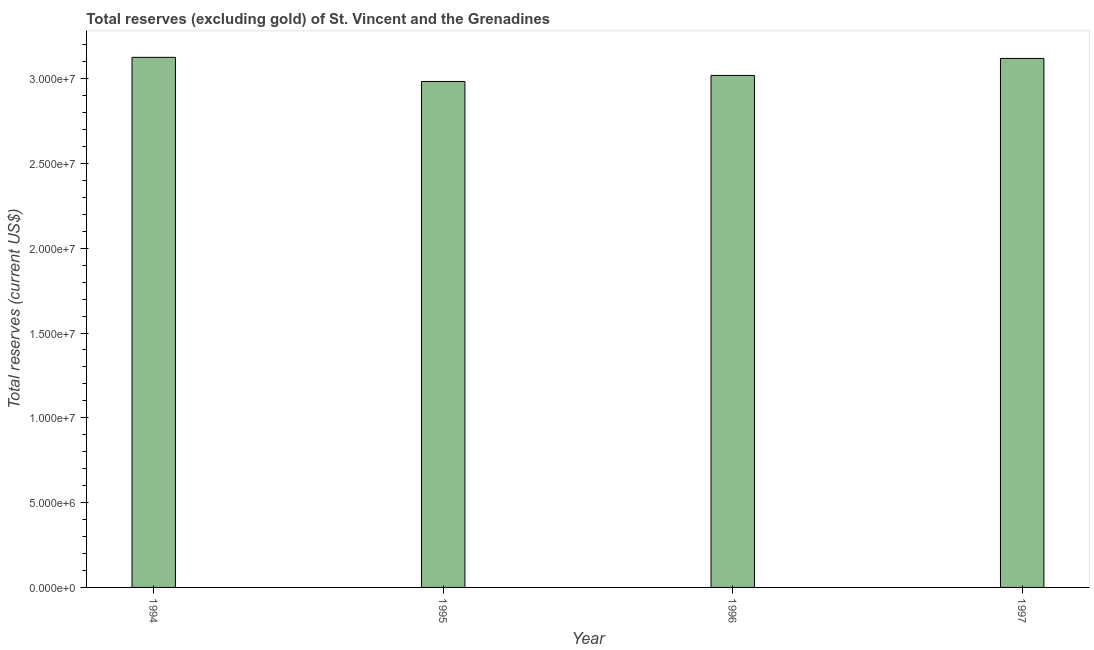What is the title of the graph?
Ensure brevity in your answer.  Total reserves (excluding gold) of St. Vincent and the Grenadines. What is the label or title of the X-axis?
Offer a very short reply. Year. What is the label or title of the Y-axis?
Ensure brevity in your answer.  Total reserves (current US$). What is the total reserves (excluding gold) in 1996?
Your answer should be very brief. 3.02e+07. Across all years, what is the maximum total reserves (excluding gold)?
Your answer should be compact. 3.13e+07. Across all years, what is the minimum total reserves (excluding gold)?
Provide a short and direct response. 2.98e+07. In which year was the total reserves (excluding gold) maximum?
Provide a short and direct response. 1994. What is the sum of the total reserves (excluding gold)?
Make the answer very short. 1.22e+08. What is the difference between the total reserves (excluding gold) in 1996 and 1997?
Provide a short and direct response. -1.00e+06. What is the average total reserves (excluding gold) per year?
Offer a terse response. 3.06e+07. What is the median total reserves (excluding gold)?
Provide a short and direct response. 3.07e+07. Do a majority of the years between 1997 and 1996 (inclusive) have total reserves (excluding gold) greater than 29000000 US$?
Offer a terse response. No. What is the ratio of the total reserves (excluding gold) in 1994 to that in 1996?
Keep it short and to the point. 1.03. Is the difference between the total reserves (excluding gold) in 1995 and 1996 greater than the difference between any two years?
Your answer should be very brief. No. What is the difference between the highest and the second highest total reserves (excluding gold)?
Provide a short and direct response. 6.53e+04. Is the sum of the total reserves (excluding gold) in 1994 and 1996 greater than the maximum total reserves (excluding gold) across all years?
Your answer should be compact. Yes. What is the difference between the highest and the lowest total reserves (excluding gold)?
Ensure brevity in your answer.  1.42e+06. In how many years, is the total reserves (excluding gold) greater than the average total reserves (excluding gold) taken over all years?
Keep it short and to the point. 2. Are all the bars in the graph horizontal?
Provide a succinct answer. No. What is the difference between two consecutive major ticks on the Y-axis?
Ensure brevity in your answer.  5.00e+06. Are the values on the major ticks of Y-axis written in scientific E-notation?
Provide a short and direct response. Yes. What is the Total reserves (current US$) in 1994?
Provide a short and direct response. 3.13e+07. What is the Total reserves (current US$) in 1995?
Offer a terse response. 2.98e+07. What is the Total reserves (current US$) of 1996?
Make the answer very short. 3.02e+07. What is the Total reserves (current US$) in 1997?
Your answer should be very brief. 3.12e+07. What is the difference between the Total reserves (current US$) in 1994 and 1995?
Offer a terse response. 1.42e+06. What is the difference between the Total reserves (current US$) in 1994 and 1996?
Give a very brief answer. 1.07e+06. What is the difference between the Total reserves (current US$) in 1994 and 1997?
Your answer should be very brief. 6.53e+04. What is the difference between the Total reserves (current US$) in 1995 and 1996?
Ensure brevity in your answer.  -3.55e+05. What is the difference between the Total reserves (current US$) in 1995 and 1997?
Your answer should be very brief. -1.36e+06. What is the difference between the Total reserves (current US$) in 1996 and 1997?
Keep it short and to the point. -1.00e+06. What is the ratio of the Total reserves (current US$) in 1994 to that in 1995?
Give a very brief answer. 1.05. What is the ratio of the Total reserves (current US$) in 1994 to that in 1996?
Your answer should be very brief. 1.03. What is the ratio of the Total reserves (current US$) in 1995 to that in 1997?
Provide a short and direct response. 0.96. What is the ratio of the Total reserves (current US$) in 1996 to that in 1997?
Keep it short and to the point. 0.97. 